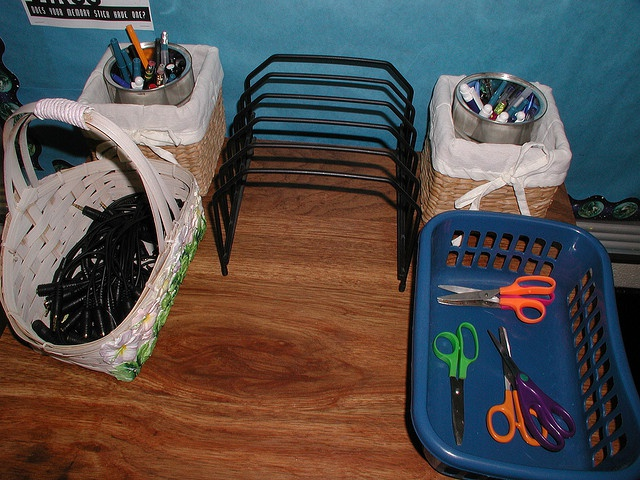Describe the objects in this image and their specific colors. I can see dining table in blue, maroon, and brown tones, scissors in blue, black, darkblue, and darkgreen tones, scissors in blue, black, navy, purple, and teal tones, scissors in blue, red, gray, navy, and salmon tones, and scissors in blue, red, navy, black, and brown tones in this image. 